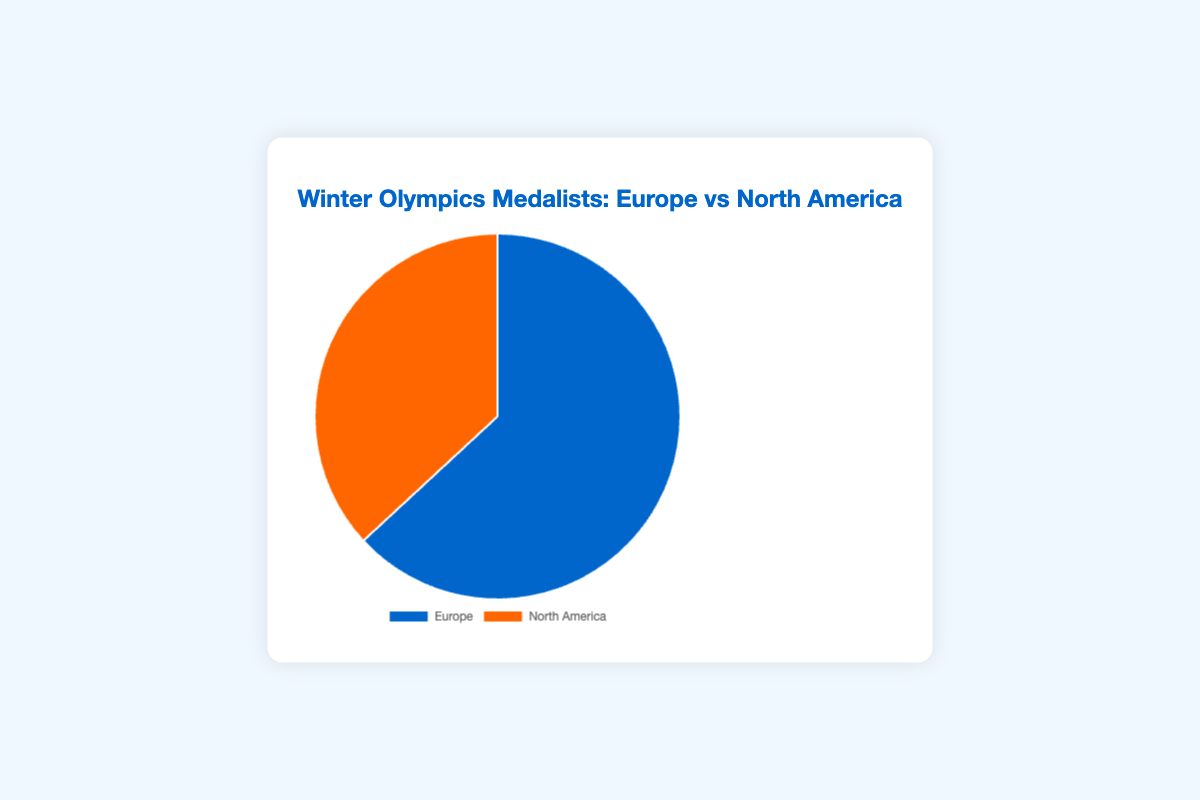Which region has more medalists? By observing the pie chart, Europe has 325 medalists whereas North America has 190, so Europe has more medalists.
Answer: Europe What is the percentage of medalists who train in Europe? To find the percentage, we first find the total number of medalists: 325 (Europe) + 190 (North America) = 515. The percentage for Europe is (325/515) * 100%. So, (325 / 515) * 100 ≈ 63.11%.
Answer: 63.11% What is the ratio of medalists in Europe to those in North America? The ratio is simply the number of medalists in Europe to the number of medalists in North America, i.e., 325:190. Simplifying this by dividing both numbers by their greatest common divisor (5), we get 65:38.
Answer: 65:38 If 100 more medalists trained in North America, how would the distribution change? Adding 100 more to North America’s 190 medalists makes 290. The total now becomes 325 (Europe) + 290 (North America) = 615. Europe's new percentage is (325/615) * 100 ≈ 52.85% and North America's is (290/615) * 100 ≈ 47.15%.
Answer: Europe: 52.85%, North America: 47.15% Considering the total number of medalists, what is the difference in count between Europe and North America? Subtract the number of medalists in North America from those in Europe: 325 - 190 = 135.
Answer: 135 If we add 50 medalists to both regions, what will the new percentages be? Adding 50 to both regions gives Europe 375 and North America 240. The new total is 375 + 240 = 615. Europe's percentage is (375/615) * 100 ≈ 60.98% and North America's is (240/615) * 100 ≈ 39.02%.
Answer: Europe: 60.98%, North America: 39.02% What color represents medalists who train in North America? The chart in the provided code uses the color #ff6600 for North America, which is typically a shade of orange.
Answer: Orange What percentage more medalists train in Europe compared to North America? First, find the difference in the number of medalists: 325 - 190 = 135. Then, calculate the percentage relative to North America: (135 / 190) * 100 ≈ 71.05%.
Answer: 71.05% By what factor is the number of European medalists greater than North American medalists? Calculate the factor by dividing the number of European medalists by North American medalists: 325 / 190 ≈ 1.71.
Answer: 1.71 